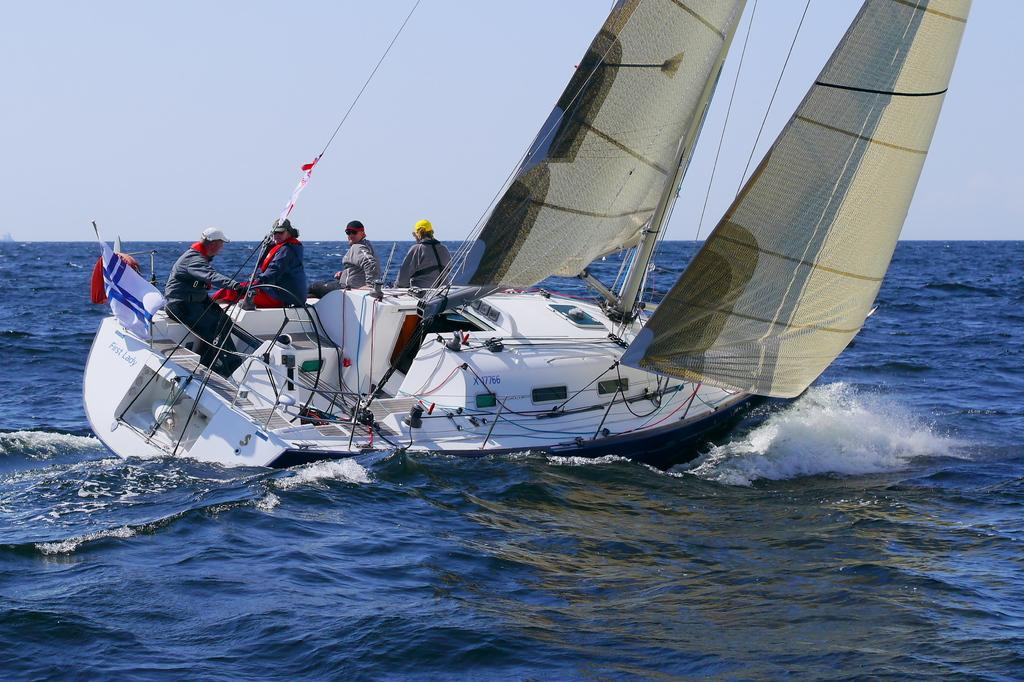What is the main subject of the image? The main subject of the image is a boat. Where is the boat located? The boat is on the water. Are there any people on the boat? Yes, there are people sitting on the boat. What else can be seen in the image besides the boat and people? There is a flag in the image. What is visible in the background of the image? The sky is visible in the background of the image. What type of base is supporting the boat in the image? The boat is on the water, not on a base, so there is no base supporting the boat in the image. 